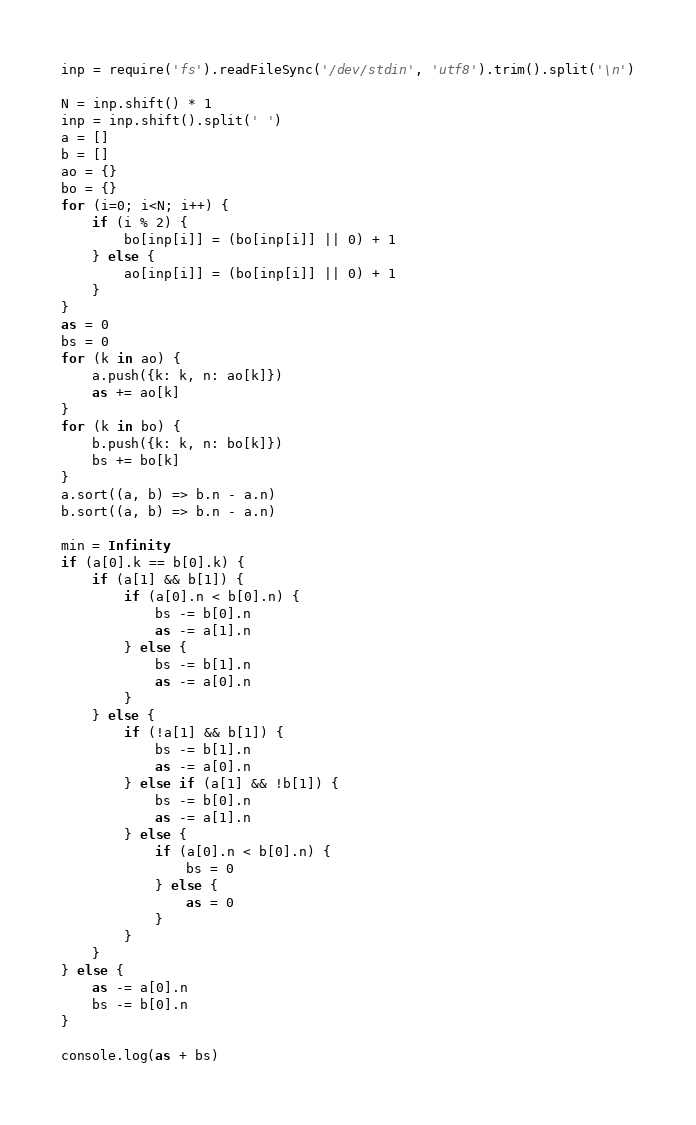Convert code to text. <code><loc_0><loc_0><loc_500><loc_500><_JavaScript_>inp = require('fs').readFileSync('/dev/stdin', 'utf8').trim().split('\n')

N = inp.shift() * 1
inp = inp.shift().split(' ')
a = []
b = []
ao = {}
bo = {}
for (i=0; i<N; i++) {
    if (i % 2) {
        bo[inp[i]] = (bo[inp[i]] || 0) + 1
    } else {
        ao[inp[i]] = (bo[inp[i]] || 0) + 1
    }
}
as = 0
bs = 0
for (k in ao) {
    a.push({k: k, n: ao[k]})
    as += ao[k]
}
for (k in bo) {
    b.push({k: k, n: bo[k]})
    bs += bo[k]
}
a.sort((a, b) => b.n - a.n)
b.sort((a, b) => b.n - a.n)

min = Infinity
if (a[0].k == b[0].k) {
    if (a[1] && b[1]) {
        if (a[0].n < b[0].n) {
            bs -= b[0].n
            as -= a[1].n
        } else {
            bs -= b[1].n
            as -= a[0].n
        }
    } else {
        if (!a[1] && b[1]) {
            bs -= b[1].n
            as -= a[0].n
        } else if (a[1] && !b[1]) {
            bs -= b[0].n
            as -= a[1].n
        } else {
            if (a[0].n < b[0].n) {
                bs = 0
            } else {
                as = 0
            }
        }
    }
} else {
    as -= a[0].n
    bs -= b[0].n
}

console.log(as + bs)</code> 